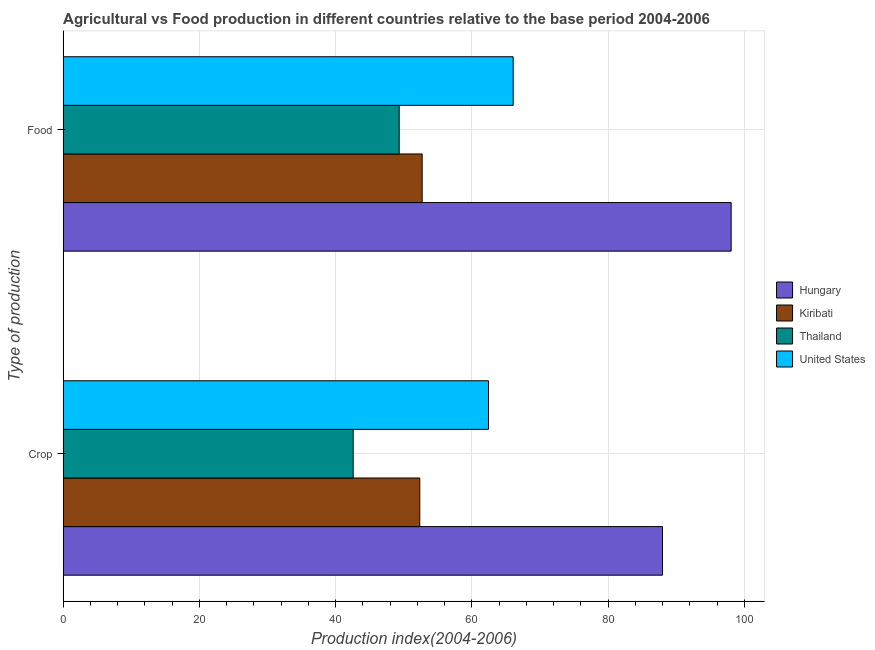How many different coloured bars are there?
Make the answer very short. 4. Are the number of bars per tick equal to the number of legend labels?
Offer a terse response. Yes. What is the label of the 2nd group of bars from the top?
Provide a succinct answer. Crop. What is the food production index in Hungary?
Provide a short and direct response. 98.07. Across all countries, what is the maximum food production index?
Give a very brief answer. 98.07. Across all countries, what is the minimum food production index?
Provide a succinct answer. 49.33. In which country was the crop production index maximum?
Your response must be concise. Hungary. In which country was the food production index minimum?
Offer a terse response. Thailand. What is the total food production index in the graph?
Ensure brevity in your answer.  266.16. What is the difference between the food production index in United States and that in Thailand?
Make the answer very short. 16.73. What is the difference between the crop production index in United States and the food production index in Thailand?
Give a very brief answer. 13.11. What is the average crop production index per country?
Ensure brevity in your answer.  61.34. What is the difference between the food production index and crop production index in Hungary?
Make the answer very short. 10.08. In how many countries, is the crop production index greater than 80 ?
Your response must be concise. 1. What is the ratio of the crop production index in United States to that in Kiribati?
Ensure brevity in your answer.  1.19. In how many countries, is the crop production index greater than the average crop production index taken over all countries?
Your answer should be compact. 2. What does the 3rd bar from the top in Food represents?
Offer a terse response. Kiribati. What does the 1st bar from the bottom in Crop represents?
Your response must be concise. Hungary. Are all the bars in the graph horizontal?
Offer a terse response. Yes. What is the difference between two consecutive major ticks on the X-axis?
Your answer should be compact. 20. Does the graph contain any zero values?
Offer a very short reply. No. Where does the legend appear in the graph?
Your response must be concise. Center right. What is the title of the graph?
Offer a terse response. Agricultural vs Food production in different countries relative to the base period 2004-2006. What is the label or title of the X-axis?
Keep it short and to the point. Production index(2004-2006). What is the label or title of the Y-axis?
Offer a very short reply. Type of production. What is the Production index(2004-2006) of Hungary in Crop?
Your answer should be very brief. 87.99. What is the Production index(2004-2006) of Kiribati in Crop?
Make the answer very short. 52.35. What is the Production index(2004-2006) of Thailand in Crop?
Provide a succinct answer. 42.57. What is the Production index(2004-2006) in United States in Crop?
Your answer should be very brief. 62.44. What is the Production index(2004-2006) of Hungary in Food?
Make the answer very short. 98.07. What is the Production index(2004-2006) of Kiribati in Food?
Your answer should be very brief. 52.7. What is the Production index(2004-2006) in Thailand in Food?
Offer a very short reply. 49.33. What is the Production index(2004-2006) in United States in Food?
Provide a short and direct response. 66.06. Across all Type of production, what is the maximum Production index(2004-2006) in Hungary?
Your response must be concise. 98.07. Across all Type of production, what is the maximum Production index(2004-2006) in Kiribati?
Offer a very short reply. 52.7. Across all Type of production, what is the maximum Production index(2004-2006) of Thailand?
Your answer should be compact. 49.33. Across all Type of production, what is the maximum Production index(2004-2006) in United States?
Offer a very short reply. 66.06. Across all Type of production, what is the minimum Production index(2004-2006) in Hungary?
Offer a terse response. 87.99. Across all Type of production, what is the minimum Production index(2004-2006) of Kiribati?
Offer a terse response. 52.35. Across all Type of production, what is the minimum Production index(2004-2006) of Thailand?
Keep it short and to the point. 42.57. Across all Type of production, what is the minimum Production index(2004-2006) of United States?
Give a very brief answer. 62.44. What is the total Production index(2004-2006) of Hungary in the graph?
Your answer should be very brief. 186.06. What is the total Production index(2004-2006) of Kiribati in the graph?
Your answer should be very brief. 105.05. What is the total Production index(2004-2006) in Thailand in the graph?
Your answer should be very brief. 91.9. What is the total Production index(2004-2006) of United States in the graph?
Offer a very short reply. 128.5. What is the difference between the Production index(2004-2006) in Hungary in Crop and that in Food?
Keep it short and to the point. -10.08. What is the difference between the Production index(2004-2006) in Kiribati in Crop and that in Food?
Offer a terse response. -0.35. What is the difference between the Production index(2004-2006) of Thailand in Crop and that in Food?
Keep it short and to the point. -6.76. What is the difference between the Production index(2004-2006) in United States in Crop and that in Food?
Your response must be concise. -3.62. What is the difference between the Production index(2004-2006) in Hungary in Crop and the Production index(2004-2006) in Kiribati in Food?
Provide a short and direct response. 35.29. What is the difference between the Production index(2004-2006) of Hungary in Crop and the Production index(2004-2006) of Thailand in Food?
Ensure brevity in your answer.  38.66. What is the difference between the Production index(2004-2006) in Hungary in Crop and the Production index(2004-2006) in United States in Food?
Offer a terse response. 21.93. What is the difference between the Production index(2004-2006) in Kiribati in Crop and the Production index(2004-2006) in Thailand in Food?
Your answer should be very brief. 3.02. What is the difference between the Production index(2004-2006) of Kiribati in Crop and the Production index(2004-2006) of United States in Food?
Keep it short and to the point. -13.71. What is the difference between the Production index(2004-2006) in Thailand in Crop and the Production index(2004-2006) in United States in Food?
Keep it short and to the point. -23.49. What is the average Production index(2004-2006) in Hungary per Type of production?
Keep it short and to the point. 93.03. What is the average Production index(2004-2006) in Kiribati per Type of production?
Your answer should be very brief. 52.52. What is the average Production index(2004-2006) in Thailand per Type of production?
Provide a short and direct response. 45.95. What is the average Production index(2004-2006) in United States per Type of production?
Give a very brief answer. 64.25. What is the difference between the Production index(2004-2006) in Hungary and Production index(2004-2006) in Kiribati in Crop?
Ensure brevity in your answer.  35.64. What is the difference between the Production index(2004-2006) of Hungary and Production index(2004-2006) of Thailand in Crop?
Your response must be concise. 45.42. What is the difference between the Production index(2004-2006) in Hungary and Production index(2004-2006) in United States in Crop?
Ensure brevity in your answer.  25.55. What is the difference between the Production index(2004-2006) of Kiribati and Production index(2004-2006) of Thailand in Crop?
Your answer should be very brief. 9.78. What is the difference between the Production index(2004-2006) in Kiribati and Production index(2004-2006) in United States in Crop?
Keep it short and to the point. -10.09. What is the difference between the Production index(2004-2006) in Thailand and Production index(2004-2006) in United States in Crop?
Ensure brevity in your answer.  -19.87. What is the difference between the Production index(2004-2006) in Hungary and Production index(2004-2006) in Kiribati in Food?
Your response must be concise. 45.37. What is the difference between the Production index(2004-2006) in Hungary and Production index(2004-2006) in Thailand in Food?
Provide a succinct answer. 48.74. What is the difference between the Production index(2004-2006) in Hungary and Production index(2004-2006) in United States in Food?
Make the answer very short. 32.01. What is the difference between the Production index(2004-2006) in Kiribati and Production index(2004-2006) in Thailand in Food?
Offer a terse response. 3.37. What is the difference between the Production index(2004-2006) of Kiribati and Production index(2004-2006) of United States in Food?
Offer a terse response. -13.36. What is the difference between the Production index(2004-2006) of Thailand and Production index(2004-2006) of United States in Food?
Keep it short and to the point. -16.73. What is the ratio of the Production index(2004-2006) of Hungary in Crop to that in Food?
Offer a terse response. 0.9. What is the ratio of the Production index(2004-2006) in Thailand in Crop to that in Food?
Your answer should be compact. 0.86. What is the ratio of the Production index(2004-2006) in United States in Crop to that in Food?
Offer a very short reply. 0.95. What is the difference between the highest and the second highest Production index(2004-2006) in Hungary?
Provide a succinct answer. 10.08. What is the difference between the highest and the second highest Production index(2004-2006) of Thailand?
Make the answer very short. 6.76. What is the difference between the highest and the second highest Production index(2004-2006) of United States?
Your response must be concise. 3.62. What is the difference between the highest and the lowest Production index(2004-2006) in Hungary?
Give a very brief answer. 10.08. What is the difference between the highest and the lowest Production index(2004-2006) of Kiribati?
Offer a very short reply. 0.35. What is the difference between the highest and the lowest Production index(2004-2006) of Thailand?
Your answer should be very brief. 6.76. What is the difference between the highest and the lowest Production index(2004-2006) of United States?
Give a very brief answer. 3.62. 